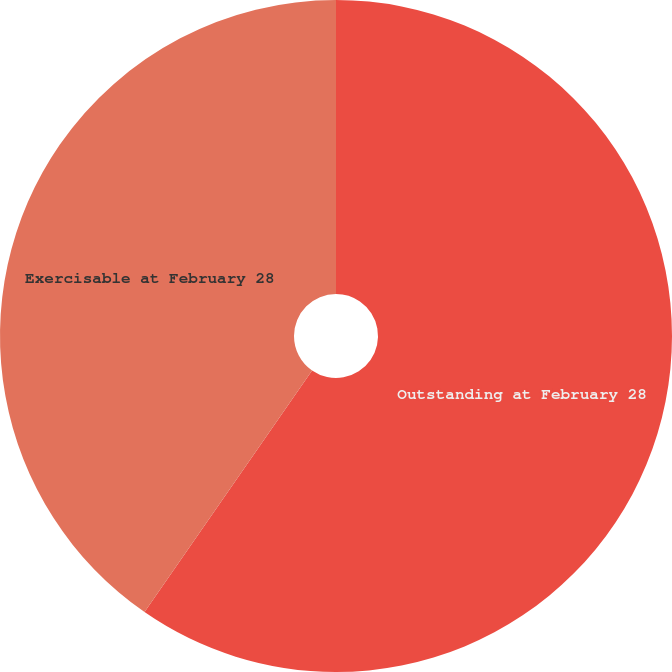<chart> <loc_0><loc_0><loc_500><loc_500><pie_chart><fcel>Outstanding at February 28<fcel>Exercisable at February 28<nl><fcel>59.65%<fcel>40.35%<nl></chart> 